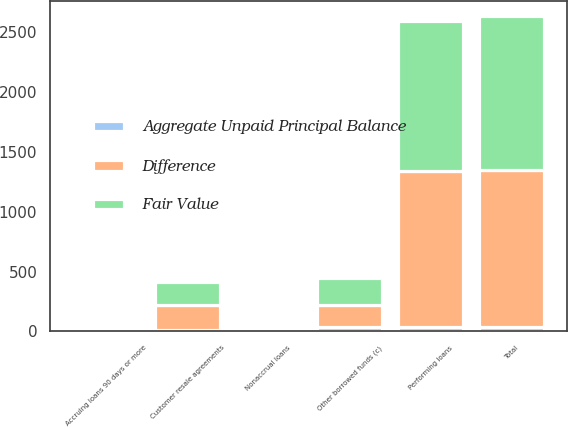<chart> <loc_0><loc_0><loc_500><loc_500><stacked_bar_chart><ecel><fcel>Customer resale agreements<fcel>Performing loans<fcel>Nonaccrual loans<fcel>Total<fcel>Accruing loans 90 days or more<fcel>Other borrowed funds (c)<nl><fcel>Difference<fcel>207<fcel>1298<fcel>15<fcel>1315<fcel>8<fcel>184<nl><fcel>Fair Value<fcel>196<fcel>1260<fcel>18<fcel>1280<fcel>14<fcel>225<nl><fcel>Aggregate Unpaid Principal Balance<fcel>11<fcel>38<fcel>3<fcel>35<fcel>6<fcel>41<nl></chart> 